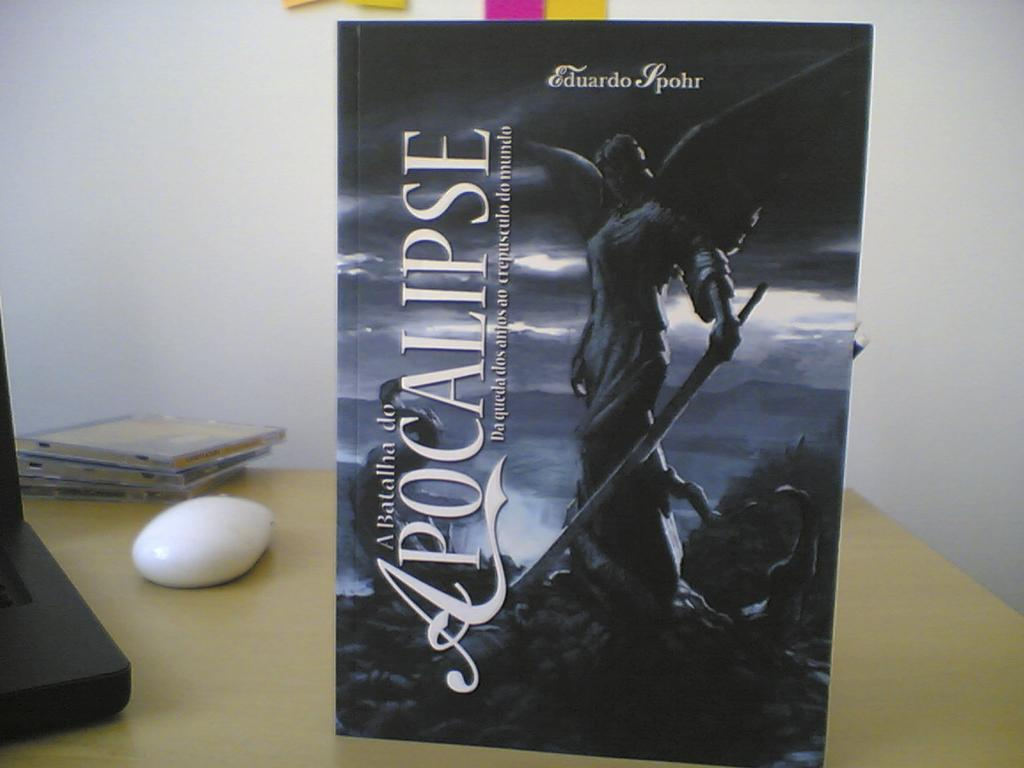<image>
Summarize the visual content of the image. Cover for a book that says the word "Apocalipse" on it. 